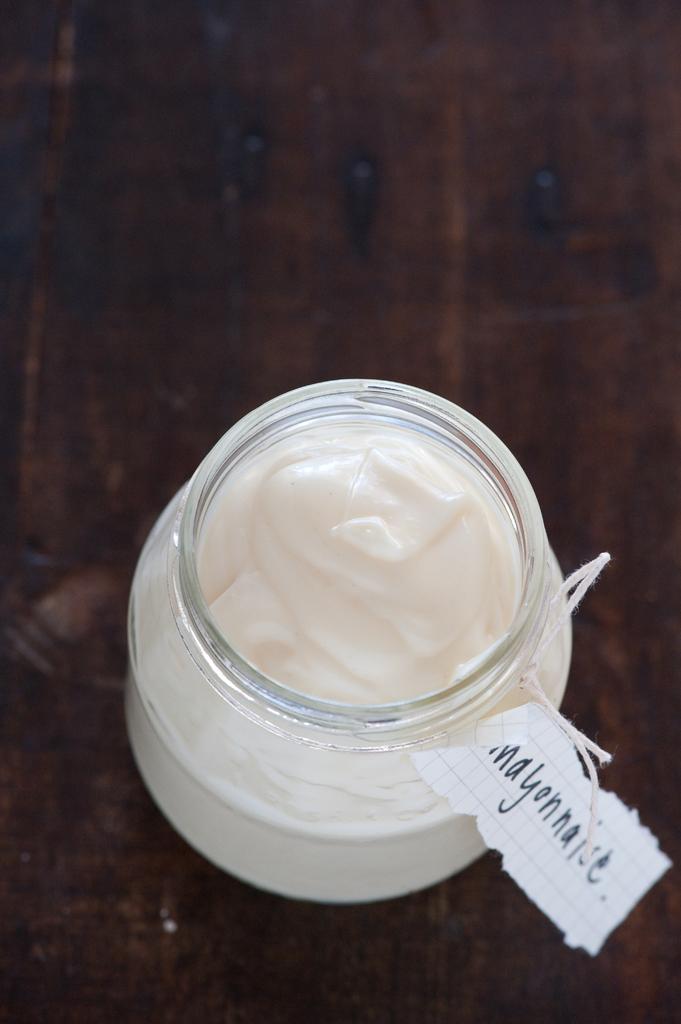What is in the jar?
Your answer should be compact. Mayonnaise. What is written on the paper?
Provide a succinct answer. Mayonnaise. 